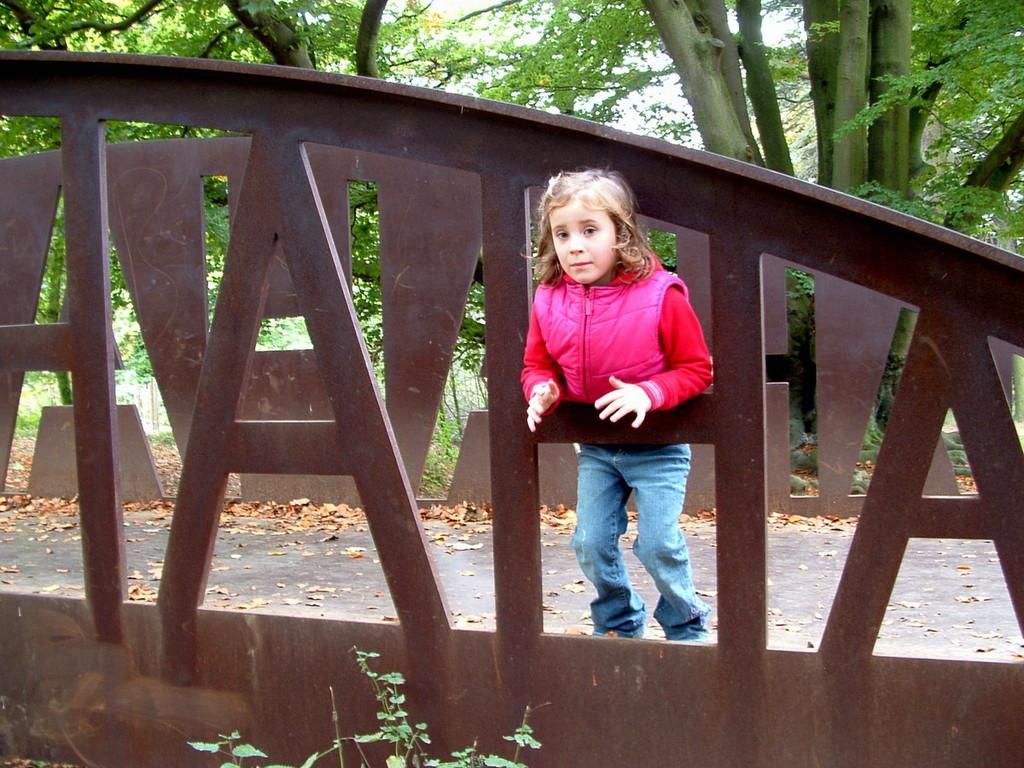What is the main subject of the image? There is a girl standing in the image. What can be seen in the foreground of the image? There is a wooden frame in the image. What is visible in the background of the image? There are trees in the backdrop of the image. How many ladybugs can be seen crawling on the wooden frame in the image? There are no ladybugs present in the image; only the girl, wooden frame, and trees are visible. 